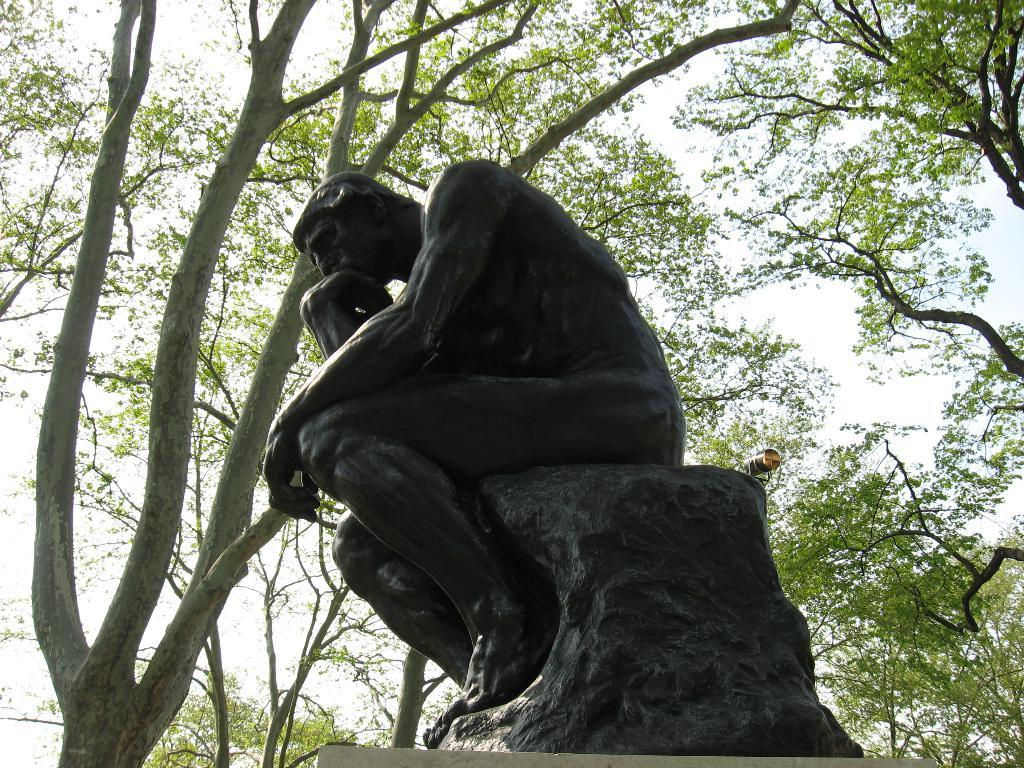What is the main subject of the image? There is a statue of a person in the image. What is the statue sitting on? The statue is sitting on a rock. What can be seen in the background of the image? There are trees and the sky visible in the background of the image. How far away is the kite from the statue in the image? There is no kite present in the image, so it cannot be determined how far away it might be from the statue. 